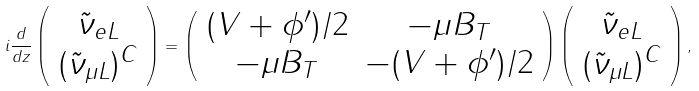<formula> <loc_0><loc_0><loc_500><loc_500>i \frac { d } { d z } \left ( \begin{array} { c } \tilde { \nu } _ { e L } \\ ( \tilde { \nu } _ { \mu L } ) ^ { C } \\ \end{array} \right ) = \left ( \begin{array} { c c } ( V + \phi ^ { \prime } ) / 2 & - \mu B _ { T } \\ - \mu B _ { T } & - ( V + \phi ^ { \prime } ) / 2 \\ \end{array} \right ) \left ( \begin{array} { c } \tilde { \nu } _ { e L } \\ ( \tilde { \nu } _ { \mu L } ) ^ { C } \\ \end{array} \right ) ,</formula> 